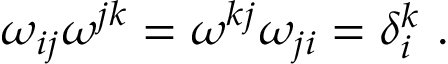Convert formula to latex. <formula><loc_0><loc_0><loc_500><loc_500>\omega _ { i j } \omega ^ { j k } = \omega ^ { k j } \omega _ { j i } = \delta _ { i } ^ { k } \ .</formula> 